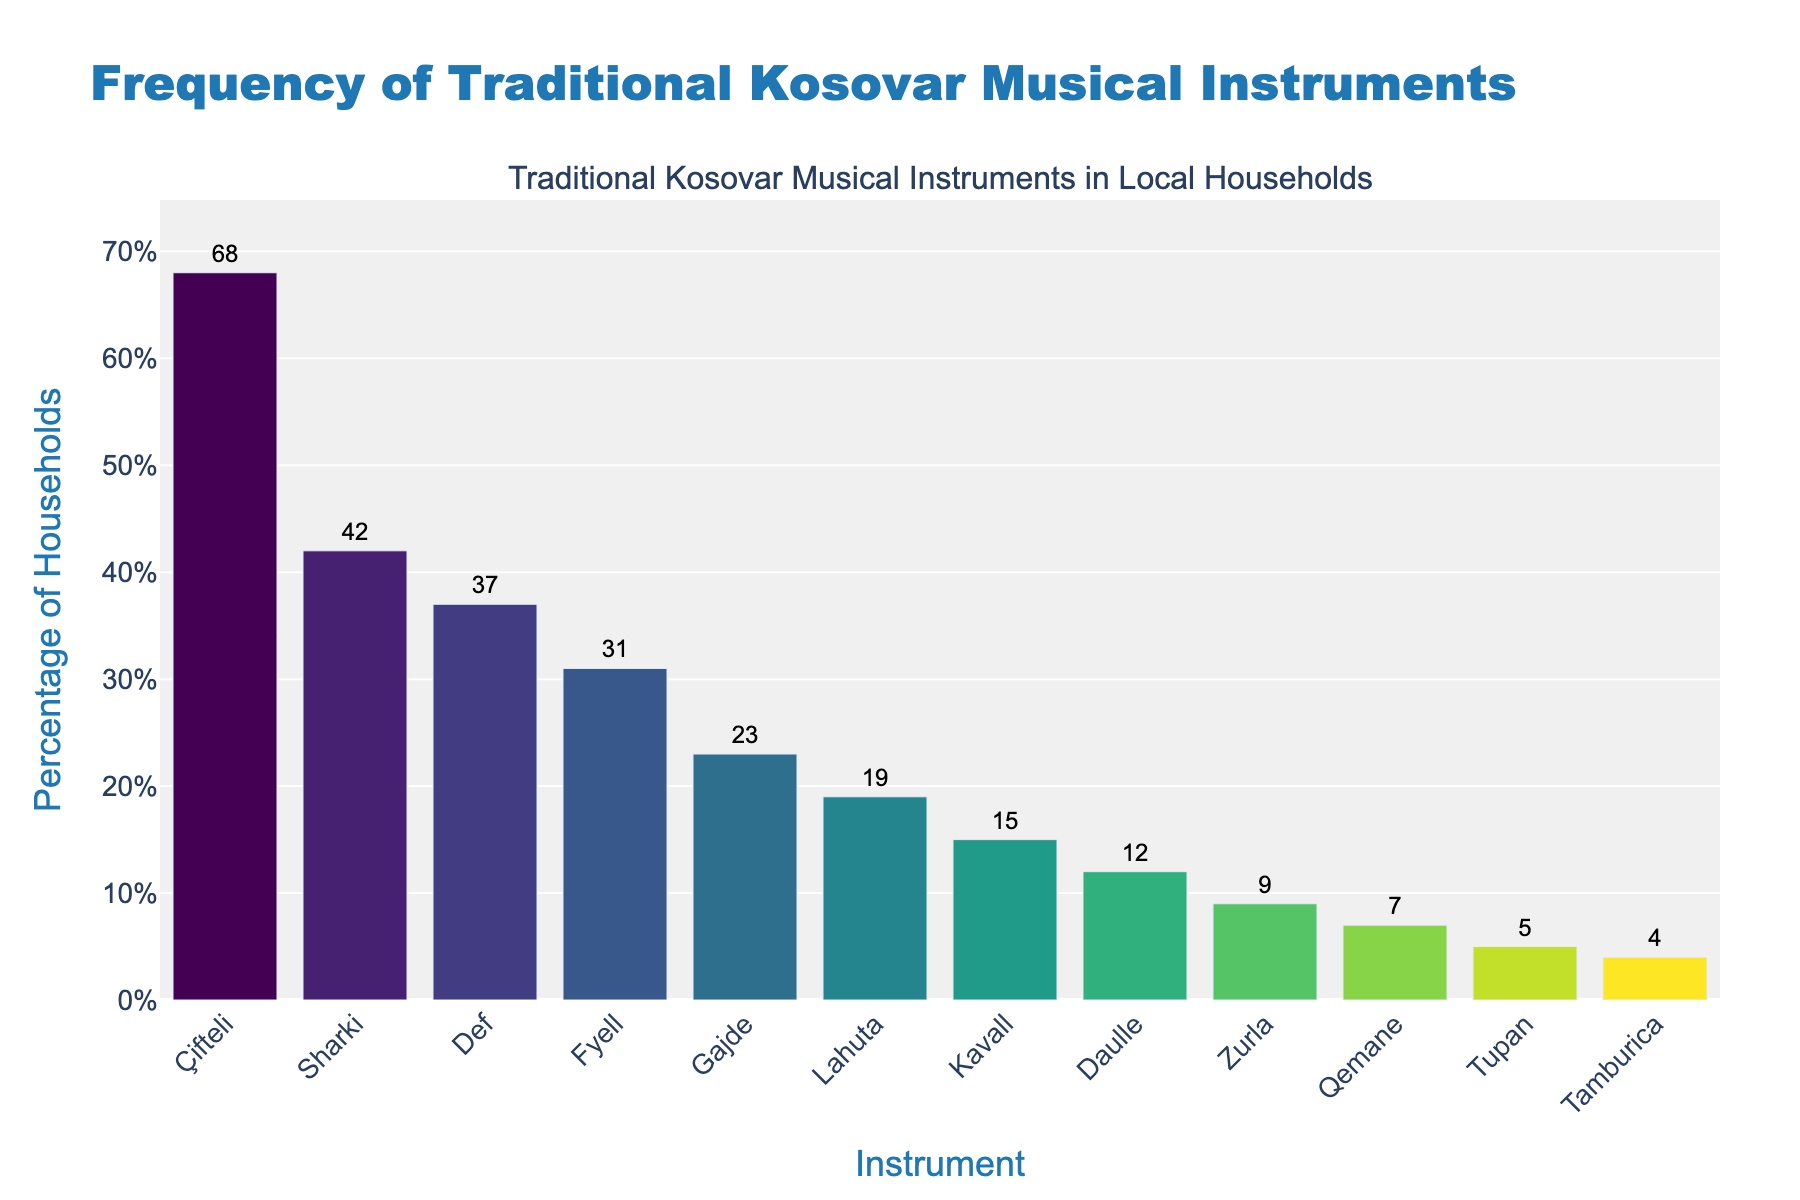What is the most frequently found traditional Kosovar musical instrument in local households? Based on the height of the bars, the instrument with the highest bar is Çifteli, indicating it's the most frequently found.
Answer: Çifteli Which instrument is found in exactly 42% of local households? The data shows that Sharki is found in 42% of local households, as indicated by the bar labeled with 42%.
Answer: Sharki Which instrument is less common: Daulle or Zurla? By comparing the heights of the bars, Daulle is found in 12% of households, while Zurla is found in 9%. Therefore, Zurla is less common.
Answer: Zurla What is the difference in the percentage of households owning a Çifteli compared to those owning a Fyell? Çifteli is found in 68% of households, and Fyell in 31%. The difference is 68% - 31% = 37%.
Answer: 37% How many instruments are found in more than 30% of households? The instruments found in more than 30% are Çifteli, Sharki, Def, and Fyell. Counting them gives 68%, 42%, 37%, and 31%, respectively. There are 4 such instruments.
Answer: 4 What is the percentage of households that own the least common instrument? The least common instrument is Tamburica with a percentage of 4%, as indicated by the shortest bar.
Answer: 4% What is the average percentage of households owning Lahuta and Kavall? The percentage of households owning Lahuta is 19%, and for Kavall, it is 15%. The average is (19% + 15%) / 2 = 17%.
Answer: 17% Which set of instruments combined make up exactly 50% of the households? The instruments are Tupan and Tamburica, with 5% and 4%, respectively, do not sum to 50%. All the percentages are different from 50%.
Answer: None Which instrument is found in more households, Gajde or Qemane? By comparing the heights of the bars, Gajde is found in 23% of households, while Qemane is found in 7%, making Gajde more common.
Answer: Gajde 